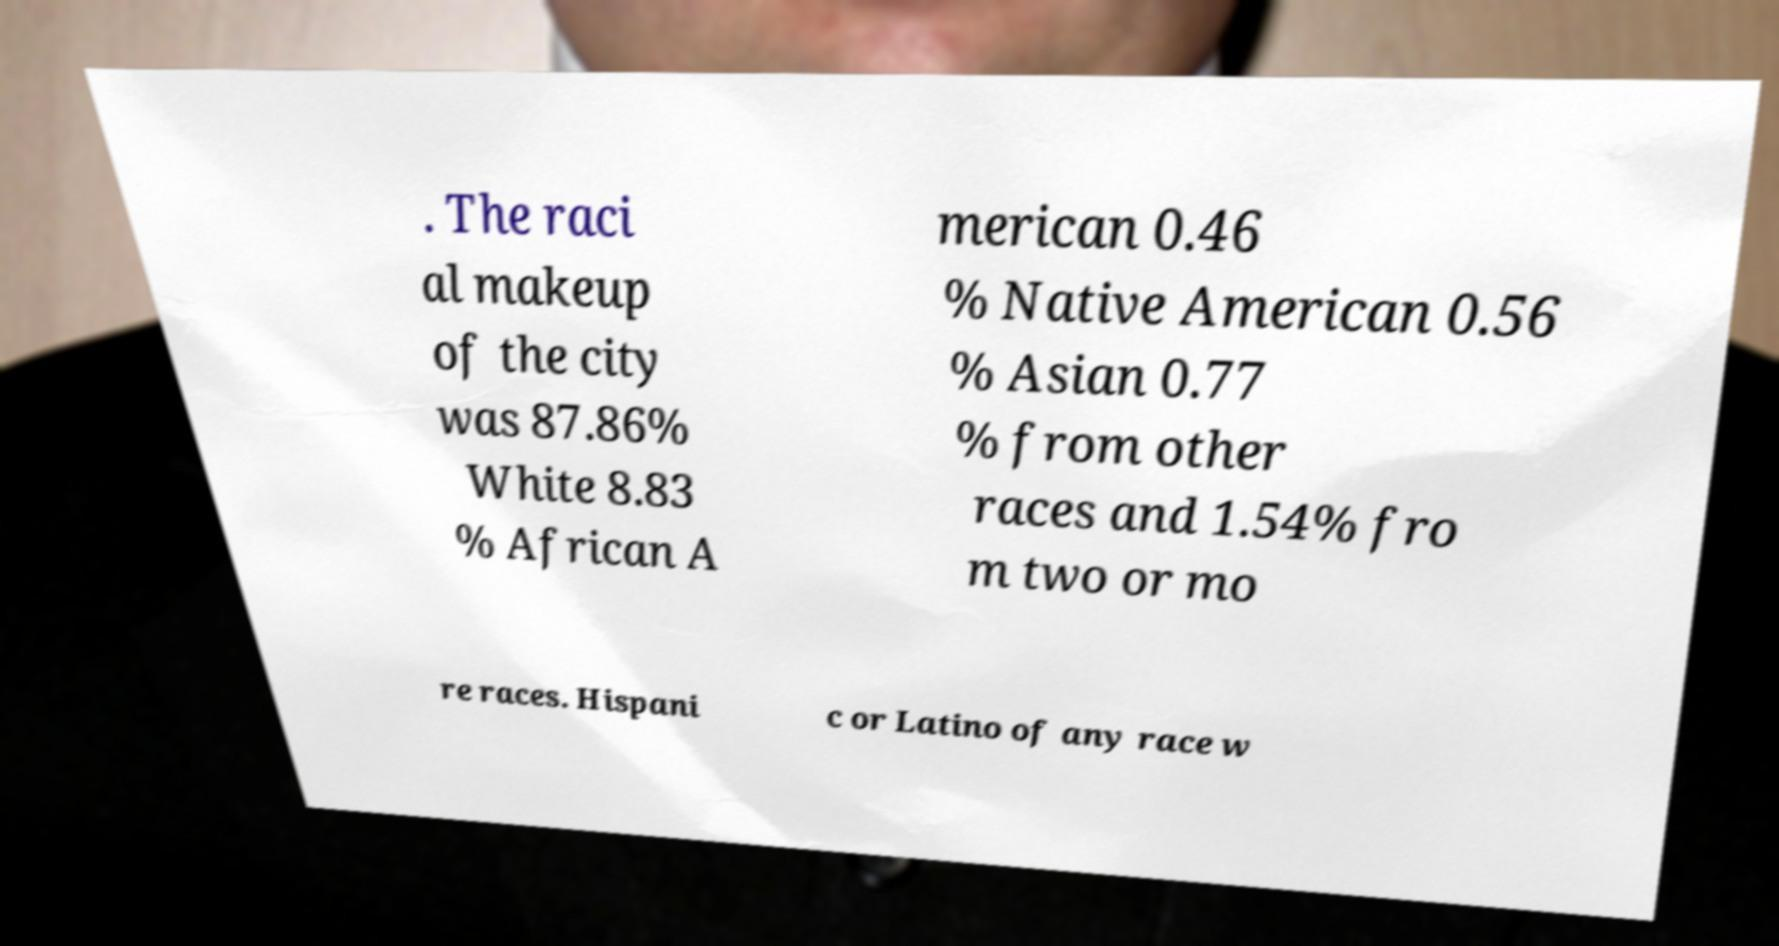Please identify and transcribe the text found in this image. . The raci al makeup of the city was 87.86% White 8.83 % African A merican 0.46 % Native American 0.56 % Asian 0.77 % from other races and 1.54% fro m two or mo re races. Hispani c or Latino of any race w 